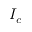<formula> <loc_0><loc_0><loc_500><loc_500>I _ { c }</formula> 